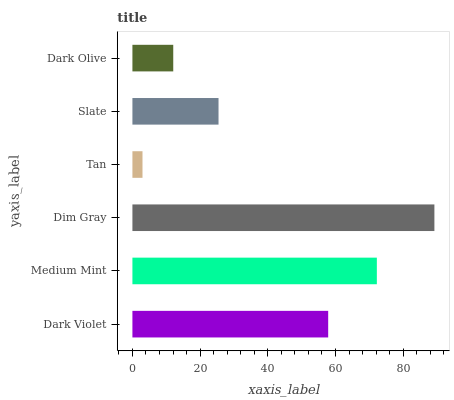Is Tan the minimum?
Answer yes or no. Yes. Is Dim Gray the maximum?
Answer yes or no. Yes. Is Medium Mint the minimum?
Answer yes or no. No. Is Medium Mint the maximum?
Answer yes or no. No. Is Medium Mint greater than Dark Violet?
Answer yes or no. Yes. Is Dark Violet less than Medium Mint?
Answer yes or no. Yes. Is Dark Violet greater than Medium Mint?
Answer yes or no. No. Is Medium Mint less than Dark Violet?
Answer yes or no. No. Is Dark Violet the high median?
Answer yes or no. Yes. Is Slate the low median?
Answer yes or no. Yes. Is Tan the high median?
Answer yes or no. No. Is Dark Violet the low median?
Answer yes or no. No. 